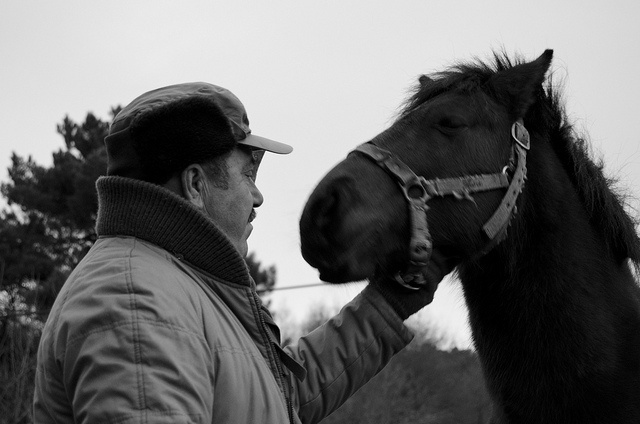Describe the objects in this image and their specific colors. I can see people in lightgray, black, and gray tones and horse in lightgray, black, gray, and darkgray tones in this image. 